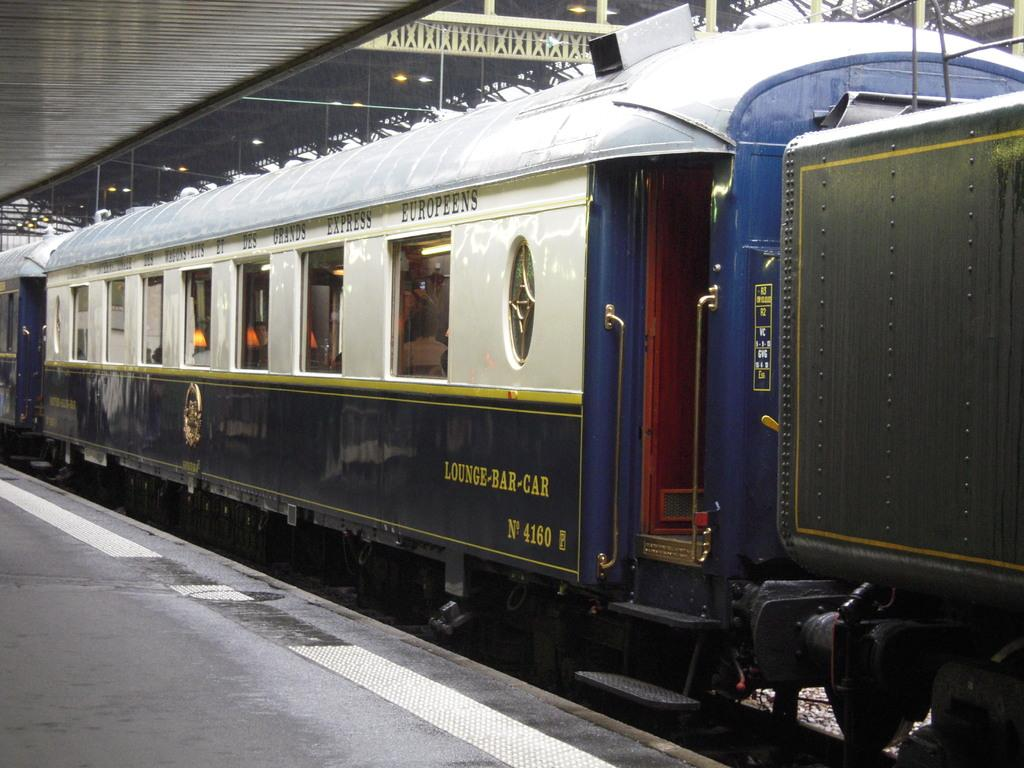Where was the image taken? The image was taken at a railway station. What is the main subject in the image? There is a train in the center of the image. What is located at the bottom of the image? There is a platform at the bottom of the image. What can be seen on the ceiling in the image? There are lights on the ceiling in the image. Can you see any toes sticking out from under the train in the image? No, there are no toes visible in the image, and no one is shown under the train. 